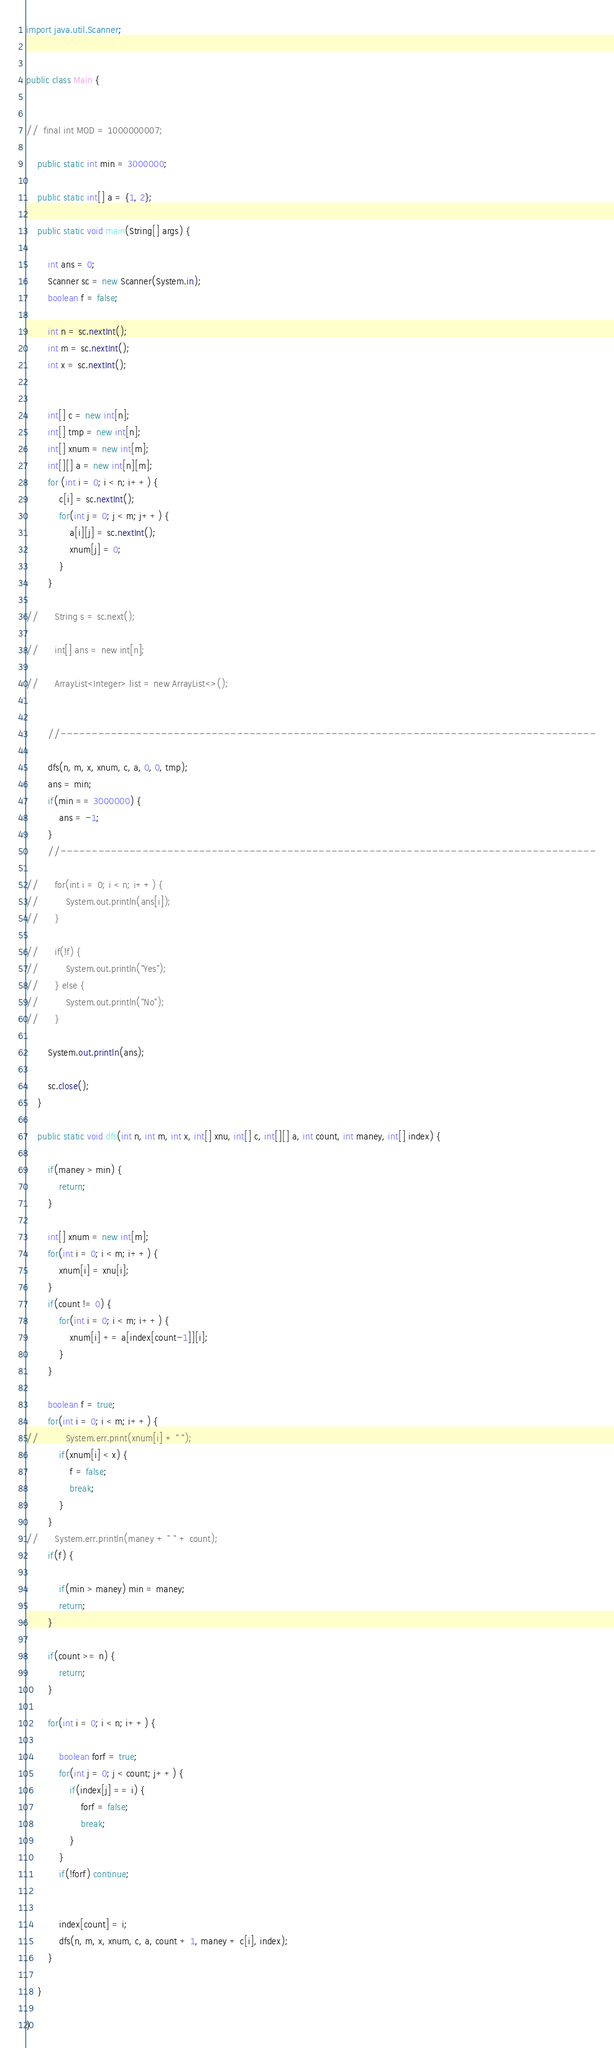<code> <loc_0><loc_0><loc_500><loc_500><_Java_>import java.util.Scanner;


public class Main {


//	final int MOD = 1000000007;

	public static int min = 3000000;

	public static int[] a = {1, 2};

	public static void main(String[] args) {

		int ans = 0;
		Scanner sc = new Scanner(System.in);
		boolean f = false;

		int n = sc.nextInt();
		int m = sc.nextInt();
		int x = sc.nextInt();


		int[] c = new int[n];
		int[] tmp = new int[n];
		int[] xnum = new int[m];
		int[][] a = new int[n][m];
		for (int i = 0; i < n; i++) {
			c[i] = sc.nextInt();
			for(int j = 0; j < m; j++) {
				a[i][j] = sc.nextInt();
				xnum[j] = 0;
			}
		}

//		String s = sc.next();

//		int[] ans = new int[n];

//		ArrayList<Integer> list = new ArrayList<>();


		//-------------------------------------------------------------------------------------

		dfs(n, m, x, xnum, c, a, 0, 0, tmp);
		ans = min;
		if(min == 3000000) {
			ans = -1;
		}
		//-------------------------------------------------------------------------------------

//		for(int i = 0; i < n; i++) {
//			System.out.println(ans[i]);
//		}

//		if(!f) {
//			System.out.println("Yes");
//		} else {
//			System.out.println("No");
//		}

		System.out.println(ans);

		sc.close();
	}

	public static void dfs(int n, int m, int x, int[] xnu, int[] c, int[][] a, int count, int maney, int[] index) {

		if(maney > min) {
			return;
		}

		int[] xnum = new int[m];
		for(int i = 0; i < m; i++) {
			xnum[i] = xnu[i];
		}
		if(count != 0) {
			for(int i = 0; i < m; i++) {
				xnum[i] += a[index[count-1]][i];
			}
		}

		boolean f = true;
		for(int i = 0; i < m; i++) {
//			System.err.print(xnum[i] + " ");
			if(xnum[i] < x) {
				f = false;
				break;
			}
		}
//		System.err.println(maney + " " + count);
		if(f) {

			if(min > maney) min = maney;
			return;
		}

		if(count >= n) {
			return;
		}

		for(int i = 0; i < n; i++) {

			boolean forf = true;
			for(int j = 0; j < count; j++) {
				if(index[j] == i) {
					forf = false;
					break;
				}
			}
			if(!forf) continue;


			index[count] = i;
			dfs(n, m, x, xnum, c, a, count + 1, maney + c[i], index);
		}

	}

}</code> 